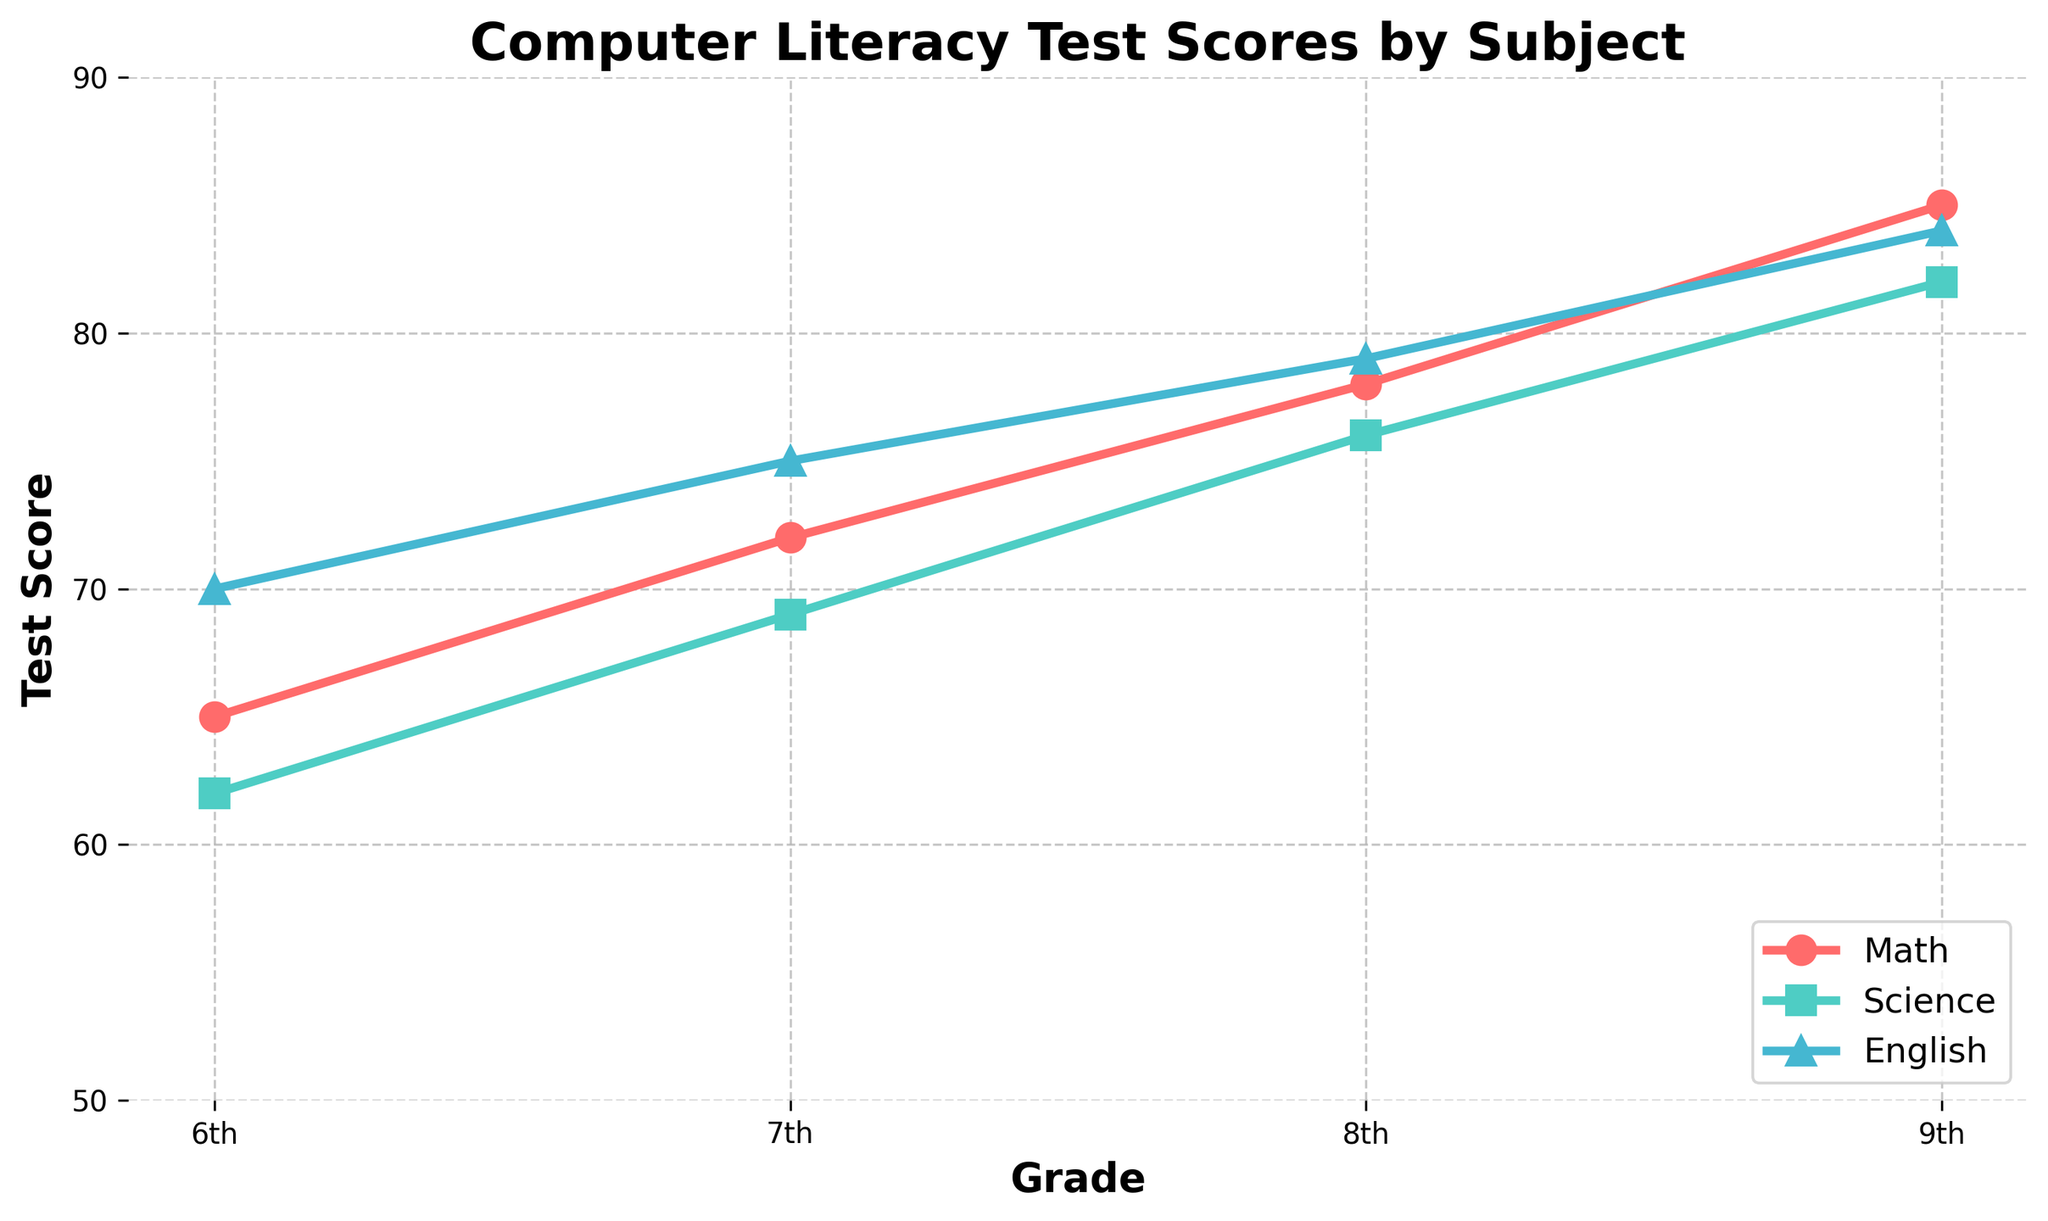What is the test score for Math in the 8th grade? To find the test score for Math in the 8th grade, look at the point where the 'Math' line intersects the '8th' grade on the x-axis.
Answer: 78 What is the difference in test scores between Science and English in the 6th grade? Identify the test scores for Science and English in the 6th grade (62 and 70 respectively). Subtract the Science score from the English score: 70 - 62 = 8.
Answer: 8 Which subject shows the greatest improvement from the 6th to the 9th grade? Calculate the improvement for each subject by subtracting their 6th-grade score from their 9th-grade score. Math: 85-65=20, Science: 82-62=20, English: 84-70=14. Compare these values; Math and Science both have the greatest improvement of 20 points.
Answer: Math and Science What is the average score of all subjects in the 7th grade? Add the test scores of all subjects in the 7th grade: 72 (Math) + 69 (Science) + 75 (English) = 216. Divide by the number of subjects (3): 216/3 = 72.
Answer: 72 Are there any grades where all subjects have the same test score? Check the test scores for Math, Science, and English for each grade. No grade has all subjects with the same test score.
Answer: No Which subject had the lowest score in the 7th grade? Compare the test scores for all subjects in the 7th grade: Math 72, Science 69, English 75. The lowest score is Science with 69.
Answer: Science How much did the English test score increase from the 6th to the 9th grade? Subtract the English test score in the 6th grade from the 9th grade: 84 - 70 = 14.
Answer: 14 What is the highest test score achieved across all grades and subjects? Identify the highest test scores for each subject in all grades. The highest scores are Math (85), Science (82), and English (84). The highest overall is Math with 85.
Answer: 85 Which subject's line is represented with a triangular marker? Look at the plot to identify the subject associated with the triangular marker (^). It is the English line.
Answer: English Between which two consecutive grades did Science show the greatest increase in test score? Compare the increase in Science scores between each consecutive grade: from 6th to 7th (69-62=7), from 7th to 8th (76-69=7), from 8th to 9th (82-76=6). The greatest increase is between the 6th and 7th grades, as well as between the 7th and 8th grades, both with an increase of 7 points.
Answer: 6th to 7th and 7th to 8th 